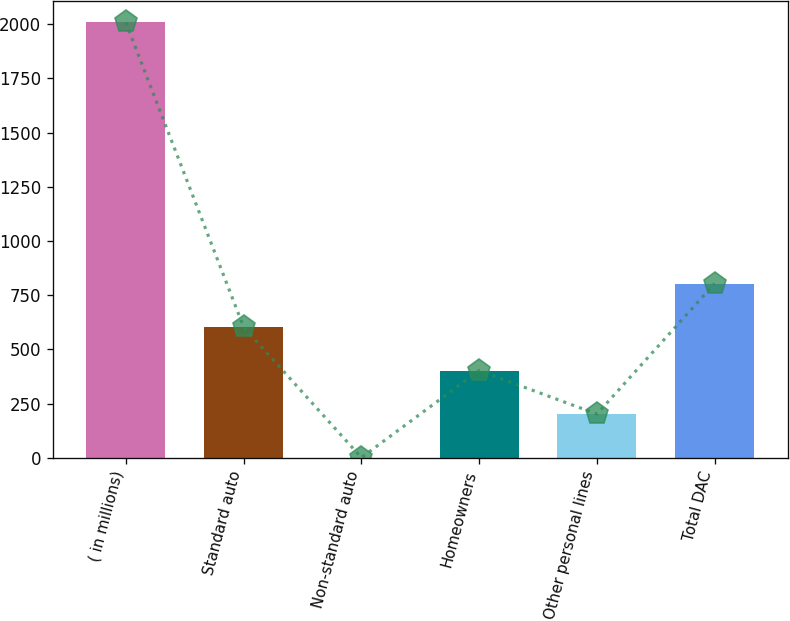Convert chart. <chart><loc_0><loc_0><loc_500><loc_500><bar_chart><fcel>( in millions)<fcel>Standard auto<fcel>Non-standard auto<fcel>Homeowners<fcel>Other personal lines<fcel>Total DAC<nl><fcel>2008<fcel>603.1<fcel>1<fcel>402.4<fcel>201.7<fcel>803.8<nl></chart> 